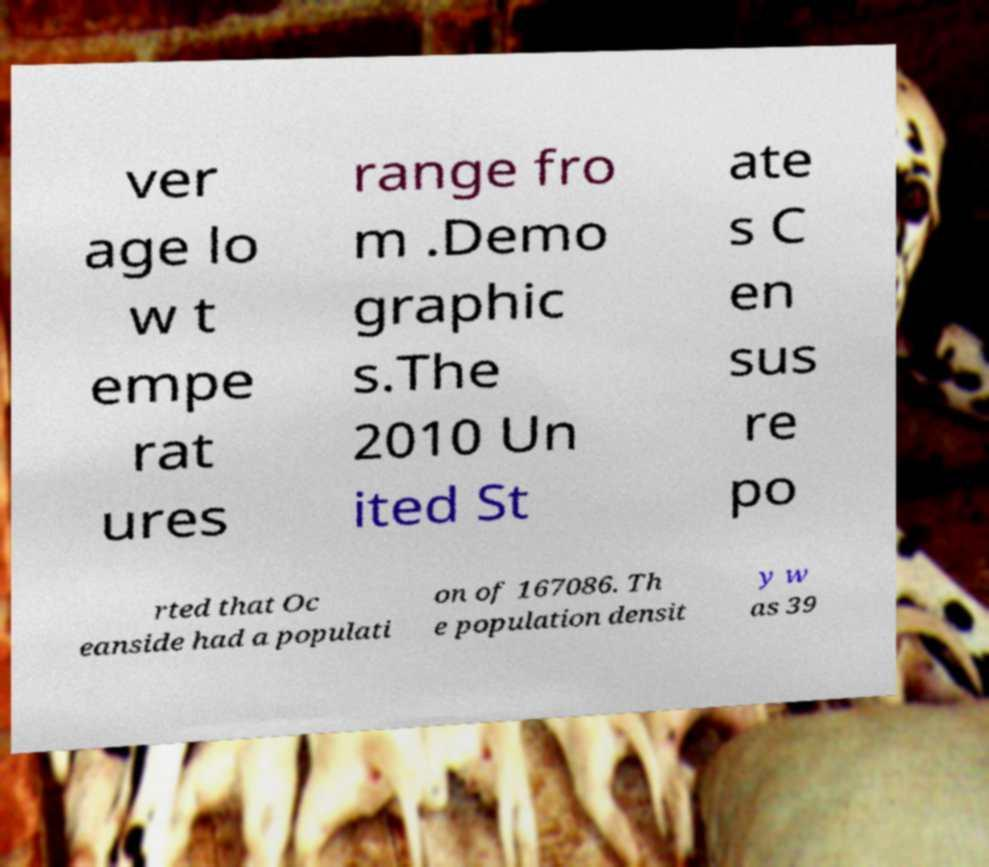Please identify and transcribe the text found in this image. ver age lo w t empe rat ures range fro m .Demo graphic s.The 2010 Un ited St ate s C en sus re po rted that Oc eanside had a populati on of 167086. Th e population densit y w as 39 